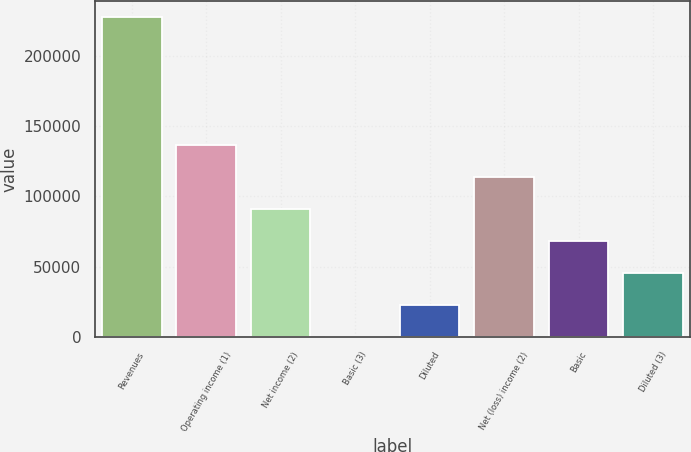Convert chart to OTSL. <chart><loc_0><loc_0><loc_500><loc_500><bar_chart><fcel>Revenues<fcel>Operating income (1)<fcel>Net income (2)<fcel>Basic (3)<fcel>Diluted<fcel>Net (loss) income (2)<fcel>Basic<fcel>Diluted (3)<nl><fcel>227857<fcel>136714<fcel>91142.8<fcel>0.08<fcel>22785.8<fcel>113929<fcel>68357.1<fcel>45571.5<nl></chart> 